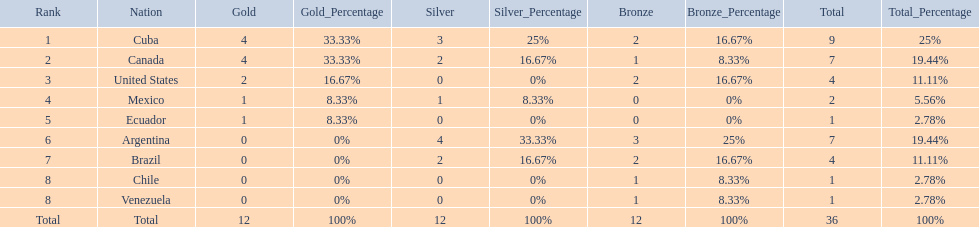What countries participated? Cuba, 4, 3, 2, Canada, 4, 2, 1, United States, 2, 0, 2, Mexico, 1, 1, 0, Ecuador, 1, 0, 0, Argentina, 0, 4, 3, Brazil, 0, 2, 2, Chile, 0, 0, 1, Venezuela, 0, 0, 1. What countries won 1 gold Mexico, 1, 1, 0, Ecuador, 1, 0, 0. What country above also won no silver? Ecuador. 